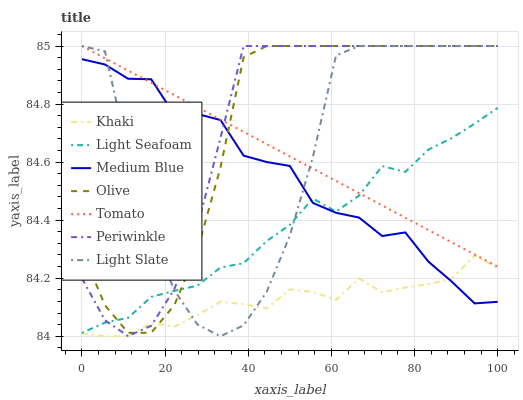Does Khaki have the minimum area under the curve?
Answer yes or no. Yes. Does Periwinkle have the maximum area under the curve?
Answer yes or no. Yes. Does Light Slate have the minimum area under the curve?
Answer yes or no. No. Does Light Slate have the maximum area under the curve?
Answer yes or no. No. Is Tomato the smoothest?
Answer yes or no. Yes. Is Light Slate the roughest?
Answer yes or no. Yes. Is Khaki the smoothest?
Answer yes or no. No. Is Khaki the roughest?
Answer yes or no. No. Does Light Slate have the lowest value?
Answer yes or no. No. Does Olive have the highest value?
Answer yes or no. Yes. Does Khaki have the highest value?
Answer yes or no. No. Is Khaki less than Tomato?
Answer yes or no. Yes. Is Light Seafoam greater than Khaki?
Answer yes or no. Yes. Does Medium Blue intersect Tomato?
Answer yes or no. Yes. Is Medium Blue less than Tomato?
Answer yes or no. No. Is Medium Blue greater than Tomato?
Answer yes or no. No. Does Khaki intersect Tomato?
Answer yes or no. No. 